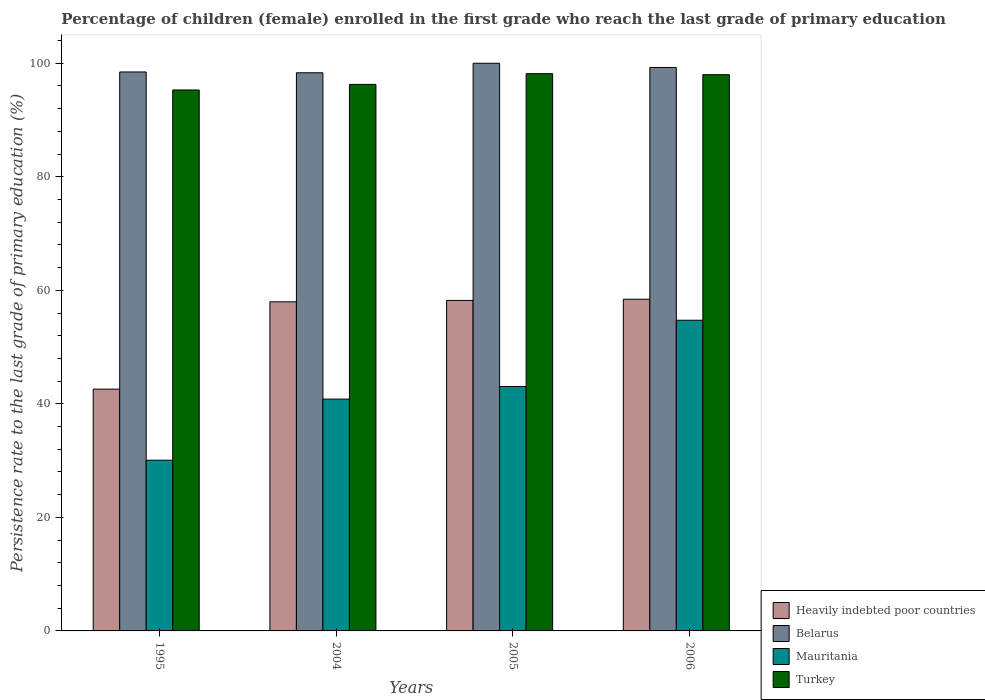How many different coloured bars are there?
Provide a short and direct response. 4. Are the number of bars per tick equal to the number of legend labels?
Offer a very short reply. Yes. Are the number of bars on each tick of the X-axis equal?
Offer a terse response. Yes. How many bars are there on the 3rd tick from the left?
Offer a terse response. 4. What is the label of the 1st group of bars from the left?
Provide a succinct answer. 1995. What is the persistence rate of children in Heavily indebted poor countries in 2006?
Ensure brevity in your answer.  58.43. Across all years, what is the maximum persistence rate of children in Mauritania?
Provide a succinct answer. 54.73. Across all years, what is the minimum persistence rate of children in Turkey?
Your answer should be compact. 95.29. In which year was the persistence rate of children in Mauritania maximum?
Ensure brevity in your answer.  2006. What is the total persistence rate of children in Heavily indebted poor countries in the graph?
Offer a very short reply. 217.22. What is the difference between the persistence rate of children in Turkey in 1995 and that in 2006?
Make the answer very short. -2.7. What is the difference between the persistence rate of children in Belarus in 2005 and the persistence rate of children in Heavily indebted poor countries in 1995?
Your answer should be very brief. 57.41. What is the average persistence rate of children in Turkey per year?
Offer a very short reply. 96.93. In the year 2004, what is the difference between the persistence rate of children in Turkey and persistence rate of children in Heavily indebted poor countries?
Keep it short and to the point. 38.3. What is the ratio of the persistence rate of children in Turkey in 1995 to that in 2005?
Your answer should be very brief. 0.97. What is the difference between the highest and the second highest persistence rate of children in Belarus?
Your answer should be compact. 0.74. What is the difference between the highest and the lowest persistence rate of children in Turkey?
Make the answer very short. 2.87. In how many years, is the persistence rate of children in Belarus greater than the average persistence rate of children in Belarus taken over all years?
Keep it short and to the point. 2. Is the sum of the persistence rate of children in Mauritania in 1995 and 2005 greater than the maximum persistence rate of children in Turkey across all years?
Provide a succinct answer. No. Is it the case that in every year, the sum of the persistence rate of children in Belarus and persistence rate of children in Mauritania is greater than the sum of persistence rate of children in Turkey and persistence rate of children in Heavily indebted poor countries?
Your response must be concise. Yes. What does the 1st bar from the left in 2006 represents?
Your answer should be compact. Heavily indebted poor countries. What does the 4th bar from the right in 2006 represents?
Offer a very short reply. Heavily indebted poor countries. Is it the case that in every year, the sum of the persistence rate of children in Heavily indebted poor countries and persistence rate of children in Belarus is greater than the persistence rate of children in Mauritania?
Your answer should be compact. Yes. How many bars are there?
Offer a terse response. 16. How many years are there in the graph?
Make the answer very short. 4. What is the difference between two consecutive major ticks on the Y-axis?
Keep it short and to the point. 20. Are the values on the major ticks of Y-axis written in scientific E-notation?
Make the answer very short. No. Does the graph contain any zero values?
Ensure brevity in your answer.  No. How many legend labels are there?
Make the answer very short. 4. How are the legend labels stacked?
Make the answer very short. Vertical. What is the title of the graph?
Your response must be concise. Percentage of children (female) enrolled in the first grade who reach the last grade of primary education. What is the label or title of the Y-axis?
Your answer should be compact. Persistence rate to the last grade of primary education (%). What is the Persistence rate to the last grade of primary education (%) of Heavily indebted poor countries in 1995?
Make the answer very short. 42.59. What is the Persistence rate to the last grade of primary education (%) in Belarus in 1995?
Offer a terse response. 98.47. What is the Persistence rate to the last grade of primary education (%) in Mauritania in 1995?
Provide a short and direct response. 30.07. What is the Persistence rate to the last grade of primary education (%) in Turkey in 1995?
Ensure brevity in your answer.  95.29. What is the Persistence rate to the last grade of primary education (%) in Heavily indebted poor countries in 2004?
Your response must be concise. 57.97. What is the Persistence rate to the last grade of primary education (%) of Belarus in 2004?
Your response must be concise. 98.32. What is the Persistence rate to the last grade of primary education (%) in Mauritania in 2004?
Your answer should be compact. 40.84. What is the Persistence rate to the last grade of primary education (%) of Turkey in 2004?
Keep it short and to the point. 96.27. What is the Persistence rate to the last grade of primary education (%) of Heavily indebted poor countries in 2005?
Make the answer very short. 58.22. What is the Persistence rate to the last grade of primary education (%) of Belarus in 2005?
Ensure brevity in your answer.  100. What is the Persistence rate to the last grade of primary education (%) in Mauritania in 2005?
Provide a succinct answer. 43.05. What is the Persistence rate to the last grade of primary education (%) of Turkey in 2005?
Your answer should be compact. 98.17. What is the Persistence rate to the last grade of primary education (%) in Heavily indebted poor countries in 2006?
Provide a short and direct response. 58.43. What is the Persistence rate to the last grade of primary education (%) of Belarus in 2006?
Provide a short and direct response. 99.26. What is the Persistence rate to the last grade of primary education (%) of Mauritania in 2006?
Make the answer very short. 54.73. What is the Persistence rate to the last grade of primary education (%) in Turkey in 2006?
Provide a short and direct response. 97.99. Across all years, what is the maximum Persistence rate to the last grade of primary education (%) in Heavily indebted poor countries?
Provide a short and direct response. 58.43. Across all years, what is the maximum Persistence rate to the last grade of primary education (%) of Belarus?
Your response must be concise. 100. Across all years, what is the maximum Persistence rate to the last grade of primary education (%) of Mauritania?
Give a very brief answer. 54.73. Across all years, what is the maximum Persistence rate to the last grade of primary education (%) in Turkey?
Offer a terse response. 98.17. Across all years, what is the minimum Persistence rate to the last grade of primary education (%) of Heavily indebted poor countries?
Ensure brevity in your answer.  42.59. Across all years, what is the minimum Persistence rate to the last grade of primary education (%) of Belarus?
Provide a succinct answer. 98.32. Across all years, what is the minimum Persistence rate to the last grade of primary education (%) of Mauritania?
Your answer should be compact. 30.07. Across all years, what is the minimum Persistence rate to the last grade of primary education (%) in Turkey?
Make the answer very short. 95.29. What is the total Persistence rate to the last grade of primary education (%) in Heavily indebted poor countries in the graph?
Your response must be concise. 217.22. What is the total Persistence rate to the last grade of primary education (%) of Belarus in the graph?
Provide a short and direct response. 396.06. What is the total Persistence rate to the last grade of primary education (%) in Mauritania in the graph?
Make the answer very short. 168.7. What is the total Persistence rate to the last grade of primary education (%) in Turkey in the graph?
Make the answer very short. 387.73. What is the difference between the Persistence rate to the last grade of primary education (%) in Heavily indebted poor countries in 1995 and that in 2004?
Your answer should be compact. -15.38. What is the difference between the Persistence rate to the last grade of primary education (%) of Belarus in 1995 and that in 2004?
Provide a short and direct response. 0.14. What is the difference between the Persistence rate to the last grade of primary education (%) in Mauritania in 1995 and that in 2004?
Your answer should be very brief. -10.76. What is the difference between the Persistence rate to the last grade of primary education (%) in Turkey in 1995 and that in 2004?
Your response must be concise. -0.98. What is the difference between the Persistence rate to the last grade of primary education (%) in Heavily indebted poor countries in 1995 and that in 2005?
Make the answer very short. -15.63. What is the difference between the Persistence rate to the last grade of primary education (%) of Belarus in 1995 and that in 2005?
Keep it short and to the point. -1.53. What is the difference between the Persistence rate to the last grade of primary education (%) of Mauritania in 1995 and that in 2005?
Give a very brief answer. -12.98. What is the difference between the Persistence rate to the last grade of primary education (%) of Turkey in 1995 and that in 2005?
Provide a succinct answer. -2.87. What is the difference between the Persistence rate to the last grade of primary education (%) in Heavily indebted poor countries in 1995 and that in 2006?
Give a very brief answer. -15.84. What is the difference between the Persistence rate to the last grade of primary education (%) of Belarus in 1995 and that in 2006?
Your answer should be compact. -0.79. What is the difference between the Persistence rate to the last grade of primary education (%) in Mauritania in 1995 and that in 2006?
Offer a very short reply. -24.66. What is the difference between the Persistence rate to the last grade of primary education (%) in Turkey in 1995 and that in 2006?
Provide a short and direct response. -2.7. What is the difference between the Persistence rate to the last grade of primary education (%) in Heavily indebted poor countries in 2004 and that in 2005?
Your response must be concise. -0.25. What is the difference between the Persistence rate to the last grade of primary education (%) in Belarus in 2004 and that in 2005?
Offer a terse response. -1.68. What is the difference between the Persistence rate to the last grade of primary education (%) in Mauritania in 2004 and that in 2005?
Your answer should be very brief. -2.21. What is the difference between the Persistence rate to the last grade of primary education (%) of Turkey in 2004 and that in 2005?
Your answer should be very brief. -1.89. What is the difference between the Persistence rate to the last grade of primary education (%) of Heavily indebted poor countries in 2004 and that in 2006?
Ensure brevity in your answer.  -0.46. What is the difference between the Persistence rate to the last grade of primary education (%) of Belarus in 2004 and that in 2006?
Offer a very short reply. -0.94. What is the difference between the Persistence rate to the last grade of primary education (%) in Mauritania in 2004 and that in 2006?
Your answer should be very brief. -13.89. What is the difference between the Persistence rate to the last grade of primary education (%) of Turkey in 2004 and that in 2006?
Provide a short and direct response. -1.72. What is the difference between the Persistence rate to the last grade of primary education (%) of Heavily indebted poor countries in 2005 and that in 2006?
Provide a succinct answer. -0.21. What is the difference between the Persistence rate to the last grade of primary education (%) in Belarus in 2005 and that in 2006?
Your response must be concise. 0.74. What is the difference between the Persistence rate to the last grade of primary education (%) in Mauritania in 2005 and that in 2006?
Ensure brevity in your answer.  -11.68. What is the difference between the Persistence rate to the last grade of primary education (%) of Turkey in 2005 and that in 2006?
Ensure brevity in your answer.  0.18. What is the difference between the Persistence rate to the last grade of primary education (%) of Heavily indebted poor countries in 1995 and the Persistence rate to the last grade of primary education (%) of Belarus in 2004?
Your answer should be very brief. -55.73. What is the difference between the Persistence rate to the last grade of primary education (%) in Heavily indebted poor countries in 1995 and the Persistence rate to the last grade of primary education (%) in Mauritania in 2004?
Provide a short and direct response. 1.75. What is the difference between the Persistence rate to the last grade of primary education (%) in Heavily indebted poor countries in 1995 and the Persistence rate to the last grade of primary education (%) in Turkey in 2004?
Give a very brief answer. -53.68. What is the difference between the Persistence rate to the last grade of primary education (%) of Belarus in 1995 and the Persistence rate to the last grade of primary education (%) of Mauritania in 2004?
Your response must be concise. 57.63. What is the difference between the Persistence rate to the last grade of primary education (%) of Belarus in 1995 and the Persistence rate to the last grade of primary education (%) of Turkey in 2004?
Your answer should be compact. 2.19. What is the difference between the Persistence rate to the last grade of primary education (%) in Mauritania in 1995 and the Persistence rate to the last grade of primary education (%) in Turkey in 2004?
Give a very brief answer. -66.2. What is the difference between the Persistence rate to the last grade of primary education (%) in Heavily indebted poor countries in 1995 and the Persistence rate to the last grade of primary education (%) in Belarus in 2005?
Provide a succinct answer. -57.41. What is the difference between the Persistence rate to the last grade of primary education (%) in Heavily indebted poor countries in 1995 and the Persistence rate to the last grade of primary education (%) in Mauritania in 2005?
Your answer should be compact. -0.46. What is the difference between the Persistence rate to the last grade of primary education (%) of Heavily indebted poor countries in 1995 and the Persistence rate to the last grade of primary education (%) of Turkey in 2005?
Provide a short and direct response. -55.57. What is the difference between the Persistence rate to the last grade of primary education (%) in Belarus in 1995 and the Persistence rate to the last grade of primary education (%) in Mauritania in 2005?
Your response must be concise. 55.42. What is the difference between the Persistence rate to the last grade of primary education (%) in Belarus in 1995 and the Persistence rate to the last grade of primary education (%) in Turkey in 2005?
Keep it short and to the point. 0.3. What is the difference between the Persistence rate to the last grade of primary education (%) in Mauritania in 1995 and the Persistence rate to the last grade of primary education (%) in Turkey in 2005?
Your answer should be very brief. -68.09. What is the difference between the Persistence rate to the last grade of primary education (%) of Heavily indebted poor countries in 1995 and the Persistence rate to the last grade of primary education (%) of Belarus in 2006?
Provide a succinct answer. -56.67. What is the difference between the Persistence rate to the last grade of primary education (%) of Heavily indebted poor countries in 1995 and the Persistence rate to the last grade of primary education (%) of Mauritania in 2006?
Give a very brief answer. -12.14. What is the difference between the Persistence rate to the last grade of primary education (%) in Heavily indebted poor countries in 1995 and the Persistence rate to the last grade of primary education (%) in Turkey in 2006?
Make the answer very short. -55.4. What is the difference between the Persistence rate to the last grade of primary education (%) in Belarus in 1995 and the Persistence rate to the last grade of primary education (%) in Mauritania in 2006?
Offer a very short reply. 43.74. What is the difference between the Persistence rate to the last grade of primary education (%) in Belarus in 1995 and the Persistence rate to the last grade of primary education (%) in Turkey in 2006?
Give a very brief answer. 0.48. What is the difference between the Persistence rate to the last grade of primary education (%) in Mauritania in 1995 and the Persistence rate to the last grade of primary education (%) in Turkey in 2006?
Your answer should be compact. -67.92. What is the difference between the Persistence rate to the last grade of primary education (%) of Heavily indebted poor countries in 2004 and the Persistence rate to the last grade of primary education (%) of Belarus in 2005?
Ensure brevity in your answer.  -42.03. What is the difference between the Persistence rate to the last grade of primary education (%) of Heavily indebted poor countries in 2004 and the Persistence rate to the last grade of primary education (%) of Mauritania in 2005?
Provide a succinct answer. 14.92. What is the difference between the Persistence rate to the last grade of primary education (%) in Heavily indebted poor countries in 2004 and the Persistence rate to the last grade of primary education (%) in Turkey in 2005?
Make the answer very short. -40.19. What is the difference between the Persistence rate to the last grade of primary education (%) of Belarus in 2004 and the Persistence rate to the last grade of primary education (%) of Mauritania in 2005?
Make the answer very short. 55.27. What is the difference between the Persistence rate to the last grade of primary education (%) in Belarus in 2004 and the Persistence rate to the last grade of primary education (%) in Turkey in 2005?
Offer a very short reply. 0.16. What is the difference between the Persistence rate to the last grade of primary education (%) in Mauritania in 2004 and the Persistence rate to the last grade of primary education (%) in Turkey in 2005?
Offer a terse response. -57.33. What is the difference between the Persistence rate to the last grade of primary education (%) in Heavily indebted poor countries in 2004 and the Persistence rate to the last grade of primary education (%) in Belarus in 2006?
Provide a short and direct response. -41.29. What is the difference between the Persistence rate to the last grade of primary education (%) in Heavily indebted poor countries in 2004 and the Persistence rate to the last grade of primary education (%) in Mauritania in 2006?
Provide a short and direct response. 3.24. What is the difference between the Persistence rate to the last grade of primary education (%) in Heavily indebted poor countries in 2004 and the Persistence rate to the last grade of primary education (%) in Turkey in 2006?
Ensure brevity in your answer.  -40.02. What is the difference between the Persistence rate to the last grade of primary education (%) in Belarus in 2004 and the Persistence rate to the last grade of primary education (%) in Mauritania in 2006?
Offer a very short reply. 43.59. What is the difference between the Persistence rate to the last grade of primary education (%) of Belarus in 2004 and the Persistence rate to the last grade of primary education (%) of Turkey in 2006?
Keep it short and to the point. 0.33. What is the difference between the Persistence rate to the last grade of primary education (%) in Mauritania in 2004 and the Persistence rate to the last grade of primary education (%) in Turkey in 2006?
Your answer should be compact. -57.15. What is the difference between the Persistence rate to the last grade of primary education (%) in Heavily indebted poor countries in 2005 and the Persistence rate to the last grade of primary education (%) in Belarus in 2006?
Make the answer very short. -41.04. What is the difference between the Persistence rate to the last grade of primary education (%) in Heavily indebted poor countries in 2005 and the Persistence rate to the last grade of primary education (%) in Mauritania in 2006?
Provide a succinct answer. 3.49. What is the difference between the Persistence rate to the last grade of primary education (%) in Heavily indebted poor countries in 2005 and the Persistence rate to the last grade of primary education (%) in Turkey in 2006?
Make the answer very short. -39.77. What is the difference between the Persistence rate to the last grade of primary education (%) of Belarus in 2005 and the Persistence rate to the last grade of primary education (%) of Mauritania in 2006?
Give a very brief answer. 45.27. What is the difference between the Persistence rate to the last grade of primary education (%) of Belarus in 2005 and the Persistence rate to the last grade of primary education (%) of Turkey in 2006?
Offer a very short reply. 2.01. What is the difference between the Persistence rate to the last grade of primary education (%) of Mauritania in 2005 and the Persistence rate to the last grade of primary education (%) of Turkey in 2006?
Provide a short and direct response. -54.94. What is the average Persistence rate to the last grade of primary education (%) in Heavily indebted poor countries per year?
Provide a short and direct response. 54.31. What is the average Persistence rate to the last grade of primary education (%) in Belarus per year?
Your response must be concise. 99.01. What is the average Persistence rate to the last grade of primary education (%) of Mauritania per year?
Offer a terse response. 42.17. What is the average Persistence rate to the last grade of primary education (%) of Turkey per year?
Your response must be concise. 96.93. In the year 1995, what is the difference between the Persistence rate to the last grade of primary education (%) in Heavily indebted poor countries and Persistence rate to the last grade of primary education (%) in Belarus?
Offer a very short reply. -55.88. In the year 1995, what is the difference between the Persistence rate to the last grade of primary education (%) of Heavily indebted poor countries and Persistence rate to the last grade of primary education (%) of Mauritania?
Keep it short and to the point. 12.52. In the year 1995, what is the difference between the Persistence rate to the last grade of primary education (%) in Heavily indebted poor countries and Persistence rate to the last grade of primary education (%) in Turkey?
Your answer should be compact. -52.7. In the year 1995, what is the difference between the Persistence rate to the last grade of primary education (%) in Belarus and Persistence rate to the last grade of primary education (%) in Mauritania?
Provide a succinct answer. 68.39. In the year 1995, what is the difference between the Persistence rate to the last grade of primary education (%) of Belarus and Persistence rate to the last grade of primary education (%) of Turkey?
Offer a terse response. 3.18. In the year 1995, what is the difference between the Persistence rate to the last grade of primary education (%) of Mauritania and Persistence rate to the last grade of primary education (%) of Turkey?
Give a very brief answer. -65.22. In the year 2004, what is the difference between the Persistence rate to the last grade of primary education (%) of Heavily indebted poor countries and Persistence rate to the last grade of primary education (%) of Belarus?
Keep it short and to the point. -40.35. In the year 2004, what is the difference between the Persistence rate to the last grade of primary education (%) of Heavily indebted poor countries and Persistence rate to the last grade of primary education (%) of Mauritania?
Make the answer very short. 17.13. In the year 2004, what is the difference between the Persistence rate to the last grade of primary education (%) in Heavily indebted poor countries and Persistence rate to the last grade of primary education (%) in Turkey?
Make the answer very short. -38.3. In the year 2004, what is the difference between the Persistence rate to the last grade of primary education (%) in Belarus and Persistence rate to the last grade of primary education (%) in Mauritania?
Provide a short and direct response. 57.49. In the year 2004, what is the difference between the Persistence rate to the last grade of primary education (%) in Belarus and Persistence rate to the last grade of primary education (%) in Turkey?
Give a very brief answer. 2.05. In the year 2004, what is the difference between the Persistence rate to the last grade of primary education (%) in Mauritania and Persistence rate to the last grade of primary education (%) in Turkey?
Keep it short and to the point. -55.44. In the year 2005, what is the difference between the Persistence rate to the last grade of primary education (%) in Heavily indebted poor countries and Persistence rate to the last grade of primary education (%) in Belarus?
Ensure brevity in your answer.  -41.78. In the year 2005, what is the difference between the Persistence rate to the last grade of primary education (%) in Heavily indebted poor countries and Persistence rate to the last grade of primary education (%) in Mauritania?
Give a very brief answer. 15.17. In the year 2005, what is the difference between the Persistence rate to the last grade of primary education (%) in Heavily indebted poor countries and Persistence rate to the last grade of primary education (%) in Turkey?
Your answer should be very brief. -39.95. In the year 2005, what is the difference between the Persistence rate to the last grade of primary education (%) of Belarus and Persistence rate to the last grade of primary education (%) of Mauritania?
Your answer should be very brief. 56.95. In the year 2005, what is the difference between the Persistence rate to the last grade of primary education (%) in Belarus and Persistence rate to the last grade of primary education (%) in Turkey?
Make the answer very short. 1.83. In the year 2005, what is the difference between the Persistence rate to the last grade of primary education (%) in Mauritania and Persistence rate to the last grade of primary education (%) in Turkey?
Offer a terse response. -55.11. In the year 2006, what is the difference between the Persistence rate to the last grade of primary education (%) of Heavily indebted poor countries and Persistence rate to the last grade of primary education (%) of Belarus?
Ensure brevity in your answer.  -40.83. In the year 2006, what is the difference between the Persistence rate to the last grade of primary education (%) in Heavily indebted poor countries and Persistence rate to the last grade of primary education (%) in Mauritania?
Offer a terse response. 3.7. In the year 2006, what is the difference between the Persistence rate to the last grade of primary education (%) in Heavily indebted poor countries and Persistence rate to the last grade of primary education (%) in Turkey?
Keep it short and to the point. -39.56. In the year 2006, what is the difference between the Persistence rate to the last grade of primary education (%) of Belarus and Persistence rate to the last grade of primary education (%) of Mauritania?
Give a very brief answer. 44.53. In the year 2006, what is the difference between the Persistence rate to the last grade of primary education (%) in Belarus and Persistence rate to the last grade of primary education (%) in Turkey?
Offer a very short reply. 1.27. In the year 2006, what is the difference between the Persistence rate to the last grade of primary education (%) of Mauritania and Persistence rate to the last grade of primary education (%) of Turkey?
Ensure brevity in your answer.  -43.26. What is the ratio of the Persistence rate to the last grade of primary education (%) in Heavily indebted poor countries in 1995 to that in 2004?
Your answer should be very brief. 0.73. What is the ratio of the Persistence rate to the last grade of primary education (%) of Mauritania in 1995 to that in 2004?
Your answer should be very brief. 0.74. What is the ratio of the Persistence rate to the last grade of primary education (%) in Heavily indebted poor countries in 1995 to that in 2005?
Keep it short and to the point. 0.73. What is the ratio of the Persistence rate to the last grade of primary education (%) in Belarus in 1995 to that in 2005?
Give a very brief answer. 0.98. What is the ratio of the Persistence rate to the last grade of primary education (%) in Mauritania in 1995 to that in 2005?
Give a very brief answer. 0.7. What is the ratio of the Persistence rate to the last grade of primary education (%) of Turkey in 1995 to that in 2005?
Your answer should be very brief. 0.97. What is the ratio of the Persistence rate to the last grade of primary education (%) of Heavily indebted poor countries in 1995 to that in 2006?
Your answer should be very brief. 0.73. What is the ratio of the Persistence rate to the last grade of primary education (%) of Mauritania in 1995 to that in 2006?
Keep it short and to the point. 0.55. What is the ratio of the Persistence rate to the last grade of primary education (%) in Turkey in 1995 to that in 2006?
Offer a very short reply. 0.97. What is the ratio of the Persistence rate to the last grade of primary education (%) of Heavily indebted poor countries in 2004 to that in 2005?
Give a very brief answer. 1. What is the ratio of the Persistence rate to the last grade of primary education (%) in Belarus in 2004 to that in 2005?
Provide a succinct answer. 0.98. What is the ratio of the Persistence rate to the last grade of primary education (%) of Mauritania in 2004 to that in 2005?
Your response must be concise. 0.95. What is the ratio of the Persistence rate to the last grade of primary education (%) of Turkey in 2004 to that in 2005?
Your answer should be very brief. 0.98. What is the ratio of the Persistence rate to the last grade of primary education (%) in Heavily indebted poor countries in 2004 to that in 2006?
Provide a short and direct response. 0.99. What is the ratio of the Persistence rate to the last grade of primary education (%) of Belarus in 2004 to that in 2006?
Offer a very short reply. 0.99. What is the ratio of the Persistence rate to the last grade of primary education (%) of Mauritania in 2004 to that in 2006?
Your answer should be very brief. 0.75. What is the ratio of the Persistence rate to the last grade of primary education (%) in Turkey in 2004 to that in 2006?
Offer a very short reply. 0.98. What is the ratio of the Persistence rate to the last grade of primary education (%) of Belarus in 2005 to that in 2006?
Give a very brief answer. 1.01. What is the ratio of the Persistence rate to the last grade of primary education (%) of Mauritania in 2005 to that in 2006?
Give a very brief answer. 0.79. What is the ratio of the Persistence rate to the last grade of primary education (%) of Turkey in 2005 to that in 2006?
Offer a terse response. 1. What is the difference between the highest and the second highest Persistence rate to the last grade of primary education (%) in Heavily indebted poor countries?
Give a very brief answer. 0.21. What is the difference between the highest and the second highest Persistence rate to the last grade of primary education (%) in Belarus?
Ensure brevity in your answer.  0.74. What is the difference between the highest and the second highest Persistence rate to the last grade of primary education (%) of Mauritania?
Make the answer very short. 11.68. What is the difference between the highest and the second highest Persistence rate to the last grade of primary education (%) in Turkey?
Offer a terse response. 0.18. What is the difference between the highest and the lowest Persistence rate to the last grade of primary education (%) in Heavily indebted poor countries?
Your response must be concise. 15.84. What is the difference between the highest and the lowest Persistence rate to the last grade of primary education (%) of Belarus?
Provide a short and direct response. 1.68. What is the difference between the highest and the lowest Persistence rate to the last grade of primary education (%) in Mauritania?
Give a very brief answer. 24.66. What is the difference between the highest and the lowest Persistence rate to the last grade of primary education (%) in Turkey?
Give a very brief answer. 2.87. 